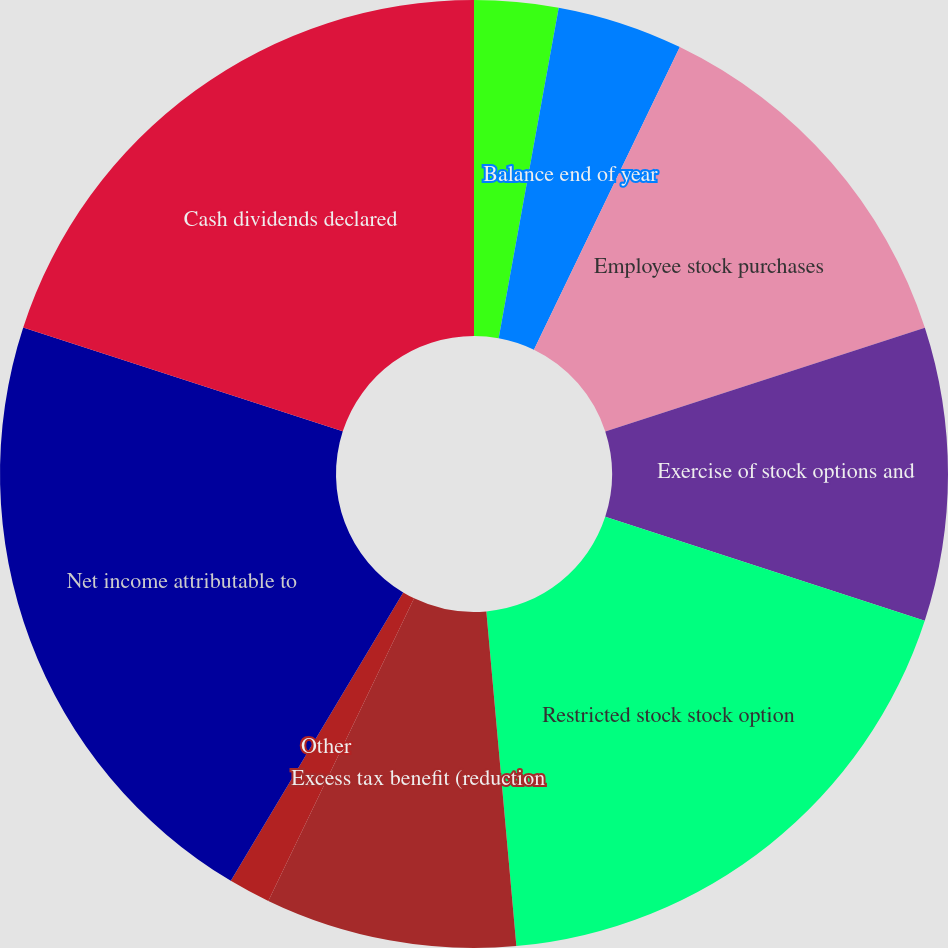Convert chart. <chart><loc_0><loc_0><loc_500><loc_500><pie_chart><fcel>Balance beginning of year<fcel>Share issuances<fcel>Balance end of year<fcel>Employee stock purchases<fcel>Exercise of stock options and<fcel>Restricted stock stock option<fcel>Excess tax benefit (reduction<fcel>Other<fcel>Net income attributable to<fcel>Cash dividends declared<nl><fcel>2.86%<fcel>0.0%<fcel>4.29%<fcel>12.86%<fcel>10.0%<fcel>18.57%<fcel>8.57%<fcel>1.43%<fcel>21.43%<fcel>20.0%<nl></chart> 